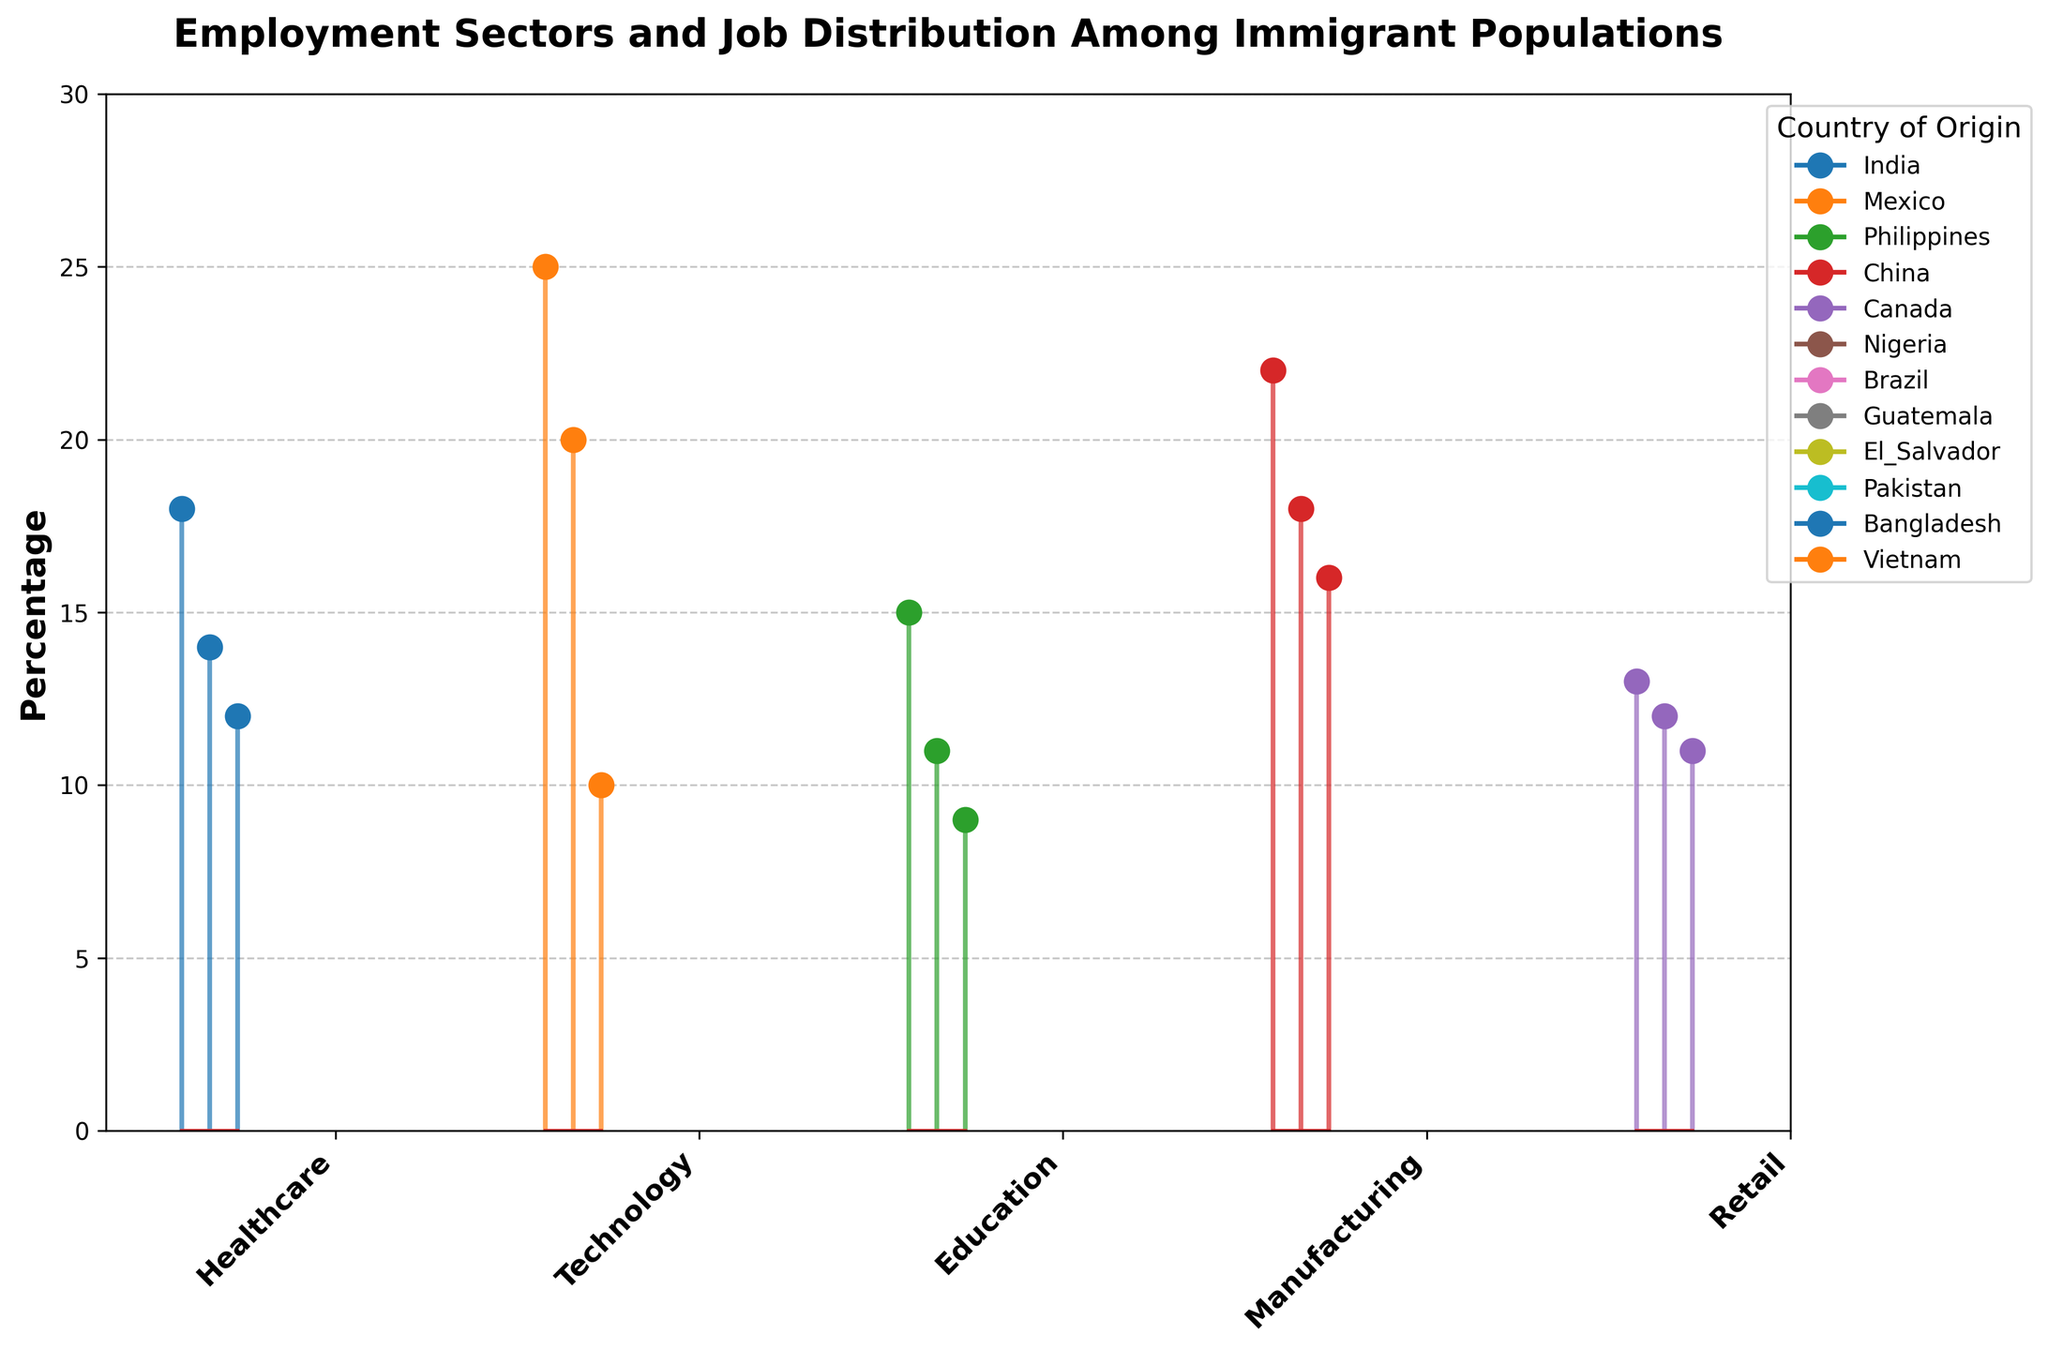How many sectors are represented in the plot? Count the number of unique sectors in the plot. There are 5 sectors: Healthcare, Technology, Education, Manufacturing, and Retail.
Answer: 5 Which country of origin has the highest percentage in the Technology sector? Look at the data points for the Technology sector and find the one with the highest percentage. India has the highest percentage at 25%.
Answer: India Compare the percentages for the Healthcare sector between India and Mexico. Which is higher? Locate the percentages for India and Mexico in the Healthcare sector and compare them. India has 18%, and Mexico has 14%, so India is higher.
Answer: India What is the combined percentage for Nigeria in the Education sector and Mexico in the Manufacturing sector? Sum the percentages for Nigeria in Education (15%) and Mexico in Manufacturing (22%). The combined percentage is 15% + 22% = 37%.
Answer: 37% What is the range of percentages in the Retail sector? Identify the maximum and minimum percentages in the Retail sector and subtract the minimum from the maximum. The highest is 13% (Pakistan), and the lowest is 11% (Vietnam), so the range is 13% - 11% = 2%.
Answer: 2% Which sector has the most countries of origin represented? Identify the number of different countries in each sector and find the maximum. Both Healthcare and Manufacturing have 3 countries each, which is the highest.
Answer: Healthcare and Manufacturing Is there any sector where the percentage for a country of origin is exactly 20%? If yes, which one? Look at all sectors and check for any data point with exactly 20%. The Technology sector has a 20% for China.
Answer: Technology For the Healthcare sector, what is the average percentage of the countries of origin listed? Sum the percentages for each country in the Healthcare sector (India 18%, Mexico 14%, Philippines 12%) and divide by the number of countries (3). The average is (18% + 14% + 12%) / 3 = 14.67%.
Answer: 14.67% What is the difference in percentage for Manufacturing sector between Mexico and El Salvador? Find the percentages for Mexico and El Salvador in the Manufacturing sector and subtract the smaller value from the larger value.  The percentage for Mexico is 22%, and for El Salvador, it is 16%, so the difference is 22% - 16% = 6%.
Answer: 6% Which sector and country combination has the smallest percentage representation? Look for the smallest percentage value in the data across all sectors and countries. The smallest percentage is in the Education sector for Brazil at 9%.
Answer: Education, Brazil 